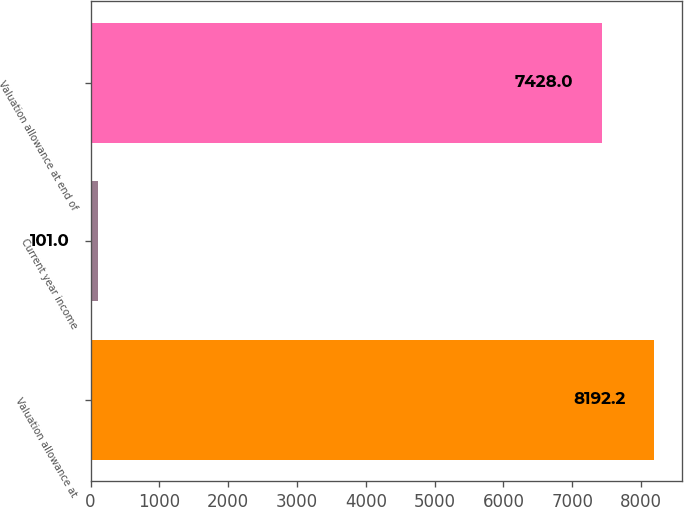Convert chart. <chart><loc_0><loc_0><loc_500><loc_500><bar_chart><fcel>Valuation allowance at<fcel>Current year income<fcel>Valuation allowance at end of<nl><fcel>8192.2<fcel>101<fcel>7428<nl></chart> 